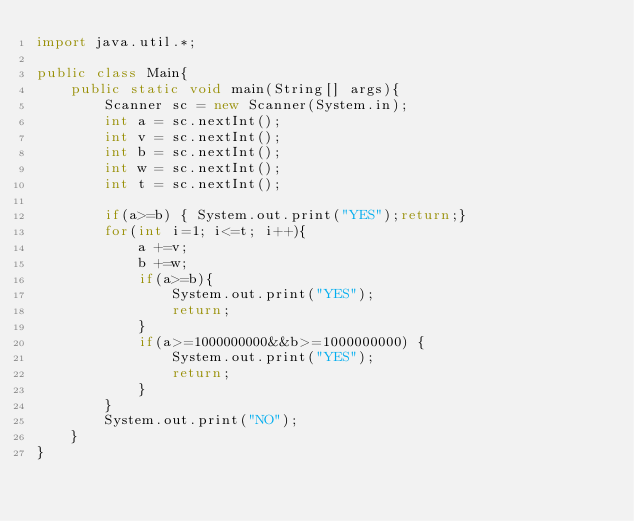Convert code to text. <code><loc_0><loc_0><loc_500><loc_500><_Java_>import java.util.*;

public class Main{
    public static void main(String[] args){
        Scanner sc = new Scanner(System.in);
        int a = sc.nextInt();
        int v = sc.nextInt();
        int b = sc.nextInt();
        int w = sc.nextInt();
        int t = sc.nextInt();

        if(a>=b) { System.out.print("YES");return;}
        for(int i=1; i<=t; i++){
            a +=v;
            b +=w;
            if(a>=b){
                System.out.print("YES");
                return;
            }
            if(a>=1000000000&&b>=1000000000) {
                System.out.print("YES");
                return;
            }
        }
        System.out.print("NO");
    }
}</code> 